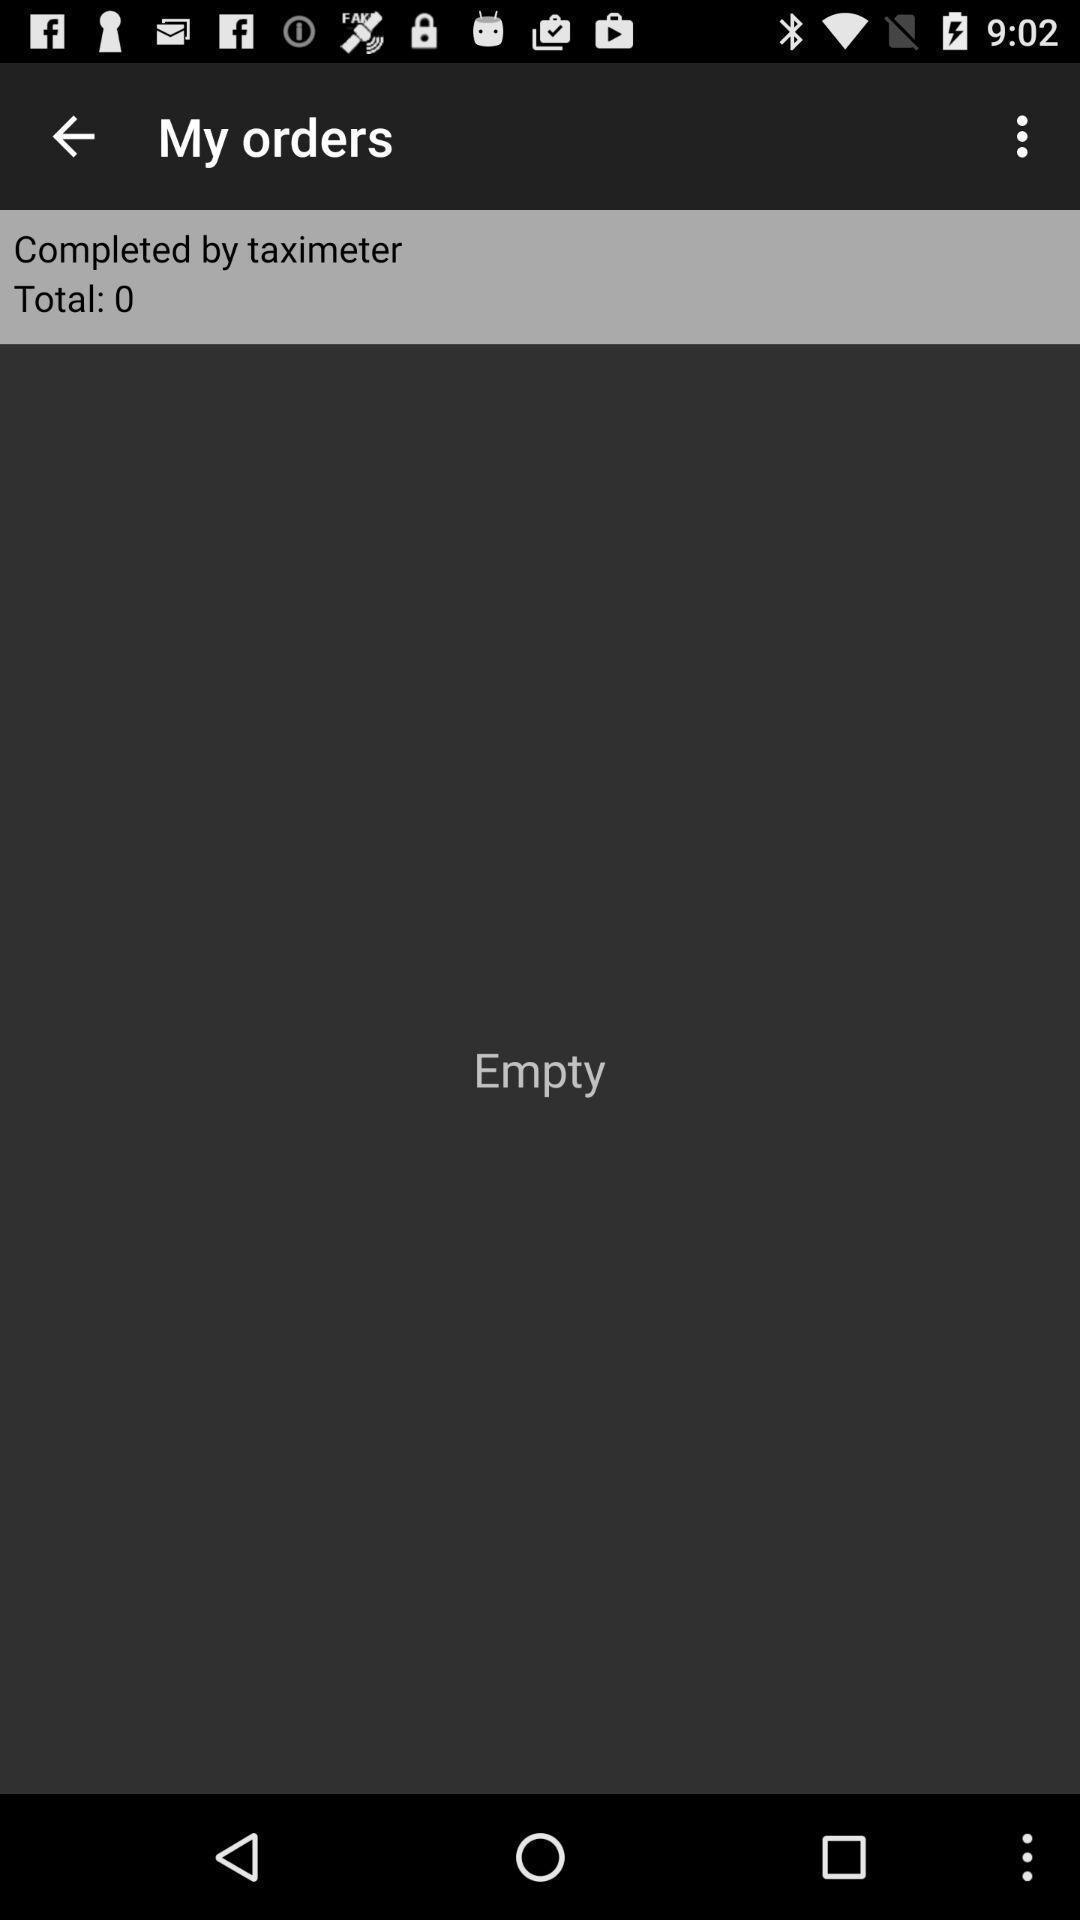Summarize the information in this screenshot. Screen displaying about the orders. 